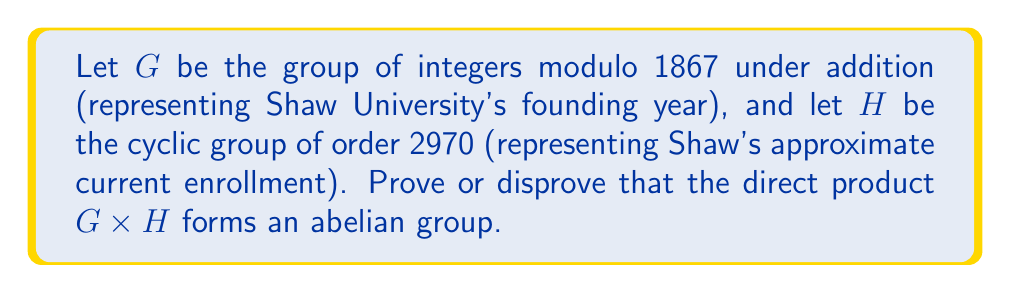Could you help me with this problem? To prove whether $G \times H$ is an abelian group, we need to check if it satisfies the properties of an abelian group:

1. Closure: This is satisfied by definition of the direct product.

2. Associativity: This is inherited from the component groups.

3. Identity element: The identity is $(0, e)$, where $0$ is the identity in $G$ and $e$ is the identity in $H$.

4. Inverse elements: For any $(a, b) \in G \times H$, the inverse is $(-a, b^{-1})$.

5. Commutativity: This is the key property we need to verify.

Let's consider two arbitrary elements $(a_1, b_1)$ and $(a_2, b_2)$ in $G \times H$.

$$(a_1, b_1) * (a_2, b_2) = (a_1 + a_2 \bmod 1867, b_1b_2)$$
$$(a_2, b_2) * (a_1, b_1) = (a_2 + a_1 \bmod 1867, b_2b_1)$$

For these to be equal:

1. $a_1 + a_2 \bmod 1867 = a_2 + a_1 \bmod 1867$, which is true because addition modulo 1867 is commutative.
2. $b_1b_2 = b_2b_1$, which is true because $H$ is cyclic and therefore abelian.

Since both component operations are commutative, the direct product operation is commutative.

Therefore, $G \times H$ satisfies all the properties of an abelian group.
Answer: The direct product $G \times H$ forms an abelian group. 